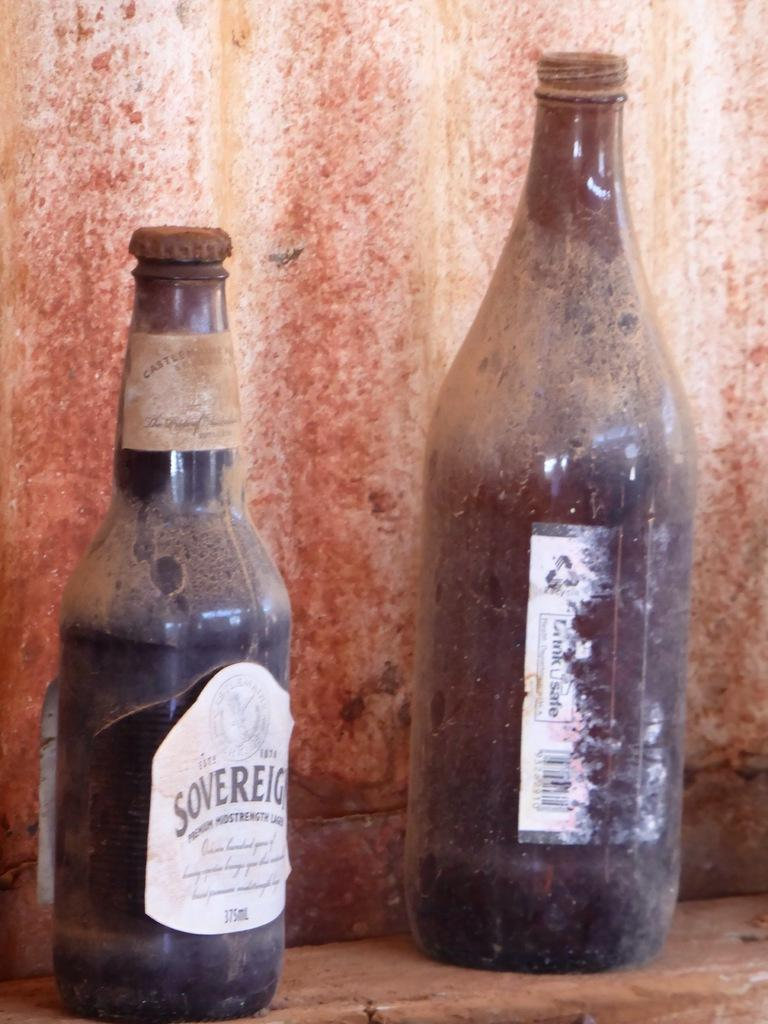<image>
Create a compact narrative representing the image presented. Two dusty old beer bottles sit on a shelf including one labeled Soverign. 